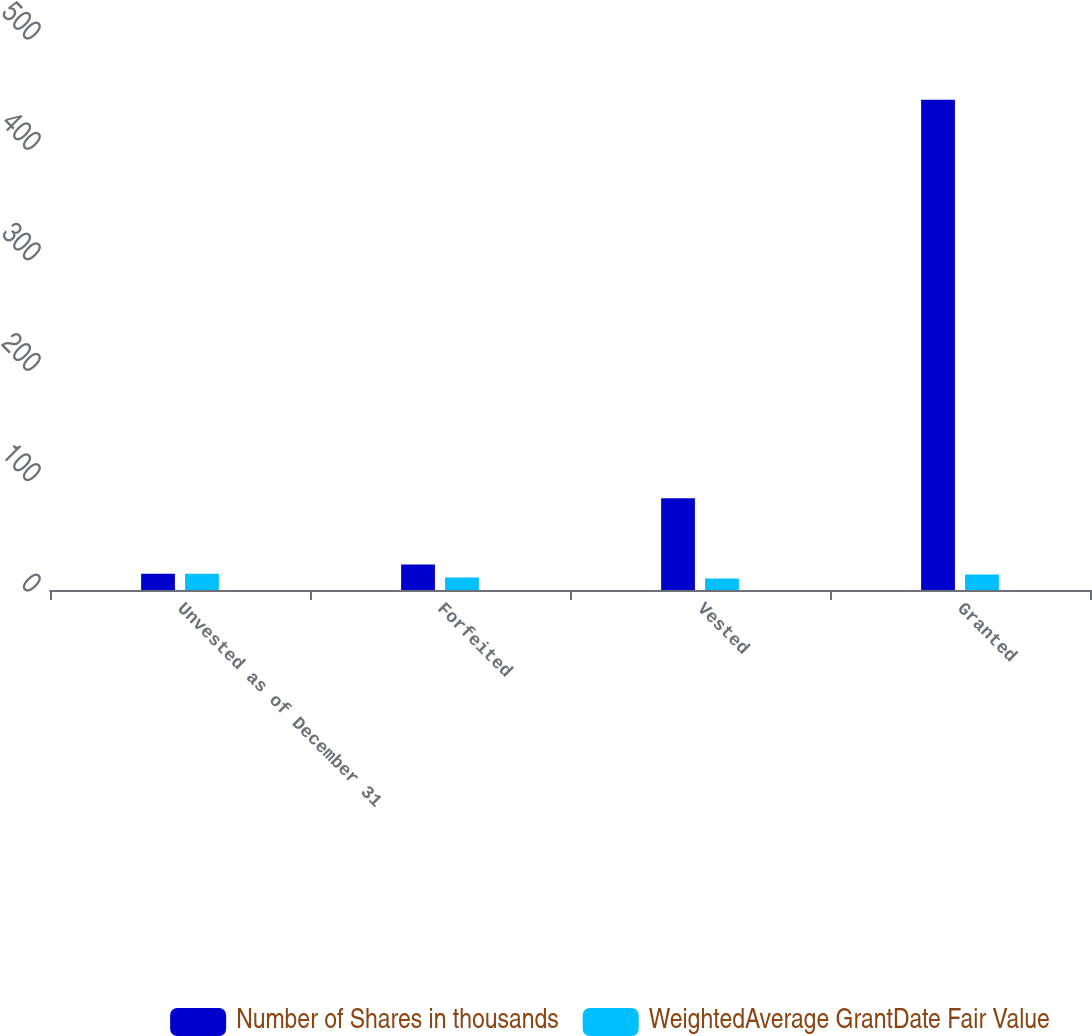Convert chart. <chart><loc_0><loc_0><loc_500><loc_500><stacked_bar_chart><ecel><fcel>Unvested as of December 31<fcel>Forfeited<fcel>Vested<fcel>Granted<nl><fcel>Number of Shares in thousands<fcel>14.7<fcel>23<fcel>83<fcel>444<nl><fcel>WeightedAverage GrantDate Fair Value<fcel>14.7<fcel>11.23<fcel>10.34<fcel>14.11<nl></chart> 